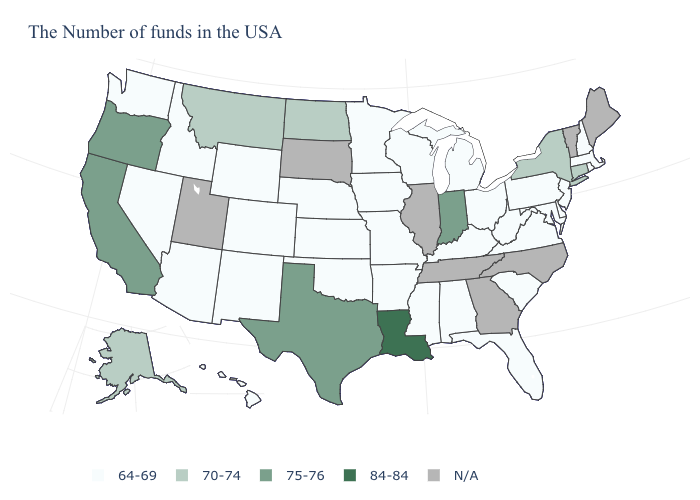Is the legend a continuous bar?
Answer briefly. No. Which states have the lowest value in the USA?
Keep it brief. Massachusetts, Rhode Island, New Hampshire, New Jersey, Delaware, Maryland, Pennsylvania, Virginia, South Carolina, West Virginia, Ohio, Florida, Michigan, Kentucky, Alabama, Wisconsin, Mississippi, Missouri, Arkansas, Minnesota, Iowa, Kansas, Nebraska, Oklahoma, Wyoming, Colorado, New Mexico, Arizona, Idaho, Nevada, Washington, Hawaii. What is the value of Kansas?
Answer briefly. 64-69. Does the map have missing data?
Be succinct. Yes. Which states have the lowest value in the Northeast?
Concise answer only. Massachusetts, Rhode Island, New Hampshire, New Jersey, Pennsylvania. How many symbols are there in the legend?
Keep it brief. 5. What is the lowest value in the USA?
Keep it brief. 64-69. Does Pennsylvania have the highest value in the Northeast?
Keep it brief. No. Does the first symbol in the legend represent the smallest category?
Keep it brief. Yes. Name the states that have a value in the range 64-69?
Concise answer only. Massachusetts, Rhode Island, New Hampshire, New Jersey, Delaware, Maryland, Pennsylvania, Virginia, South Carolina, West Virginia, Ohio, Florida, Michigan, Kentucky, Alabama, Wisconsin, Mississippi, Missouri, Arkansas, Minnesota, Iowa, Kansas, Nebraska, Oklahoma, Wyoming, Colorado, New Mexico, Arizona, Idaho, Nevada, Washington, Hawaii. What is the lowest value in states that border Oklahoma?
Short answer required. 64-69. Among the states that border Arkansas , does Oklahoma have the highest value?
Keep it brief. No. Name the states that have a value in the range 75-76?
Keep it brief. Indiana, Texas, California, Oregon. Among the states that border Arkansas , does Mississippi have the highest value?
Give a very brief answer. No. 